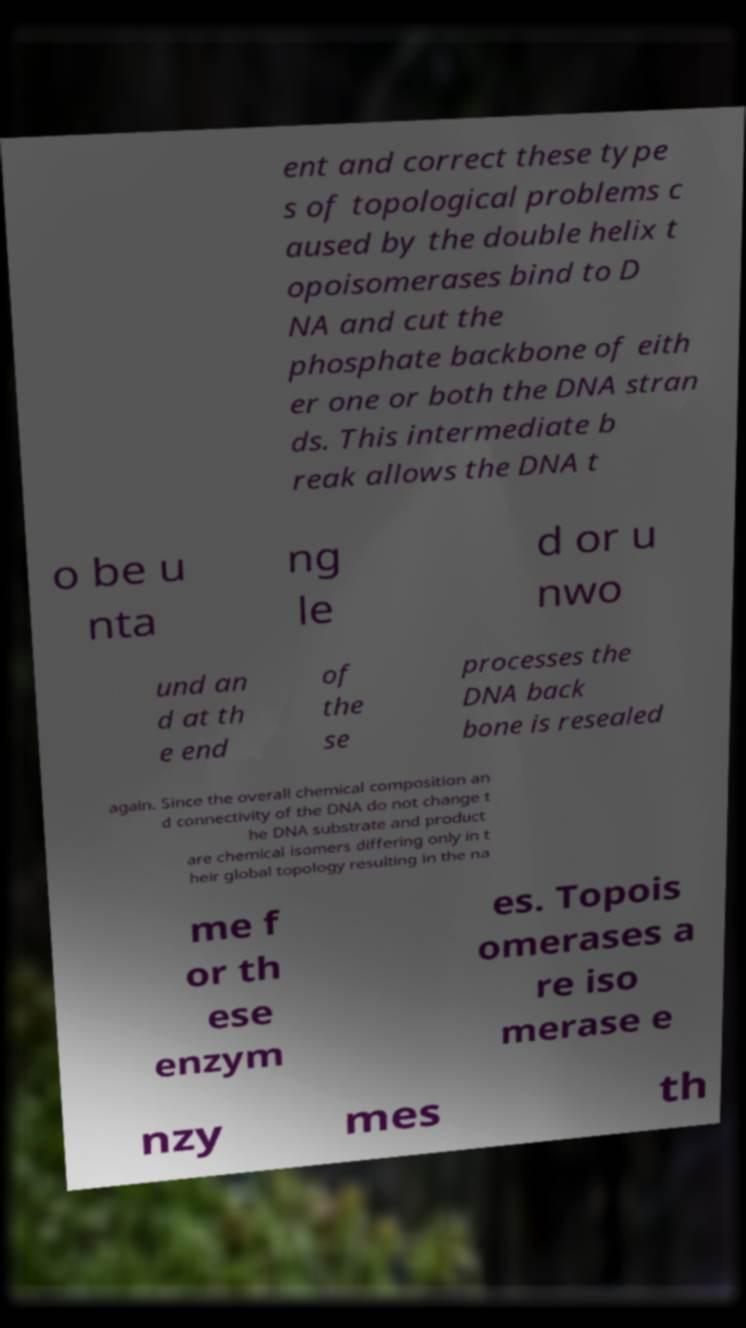Please read and relay the text visible in this image. What does it say? ent and correct these type s of topological problems c aused by the double helix t opoisomerases bind to D NA and cut the phosphate backbone of eith er one or both the DNA stran ds. This intermediate b reak allows the DNA t o be u nta ng le d or u nwo und an d at th e end of the se processes the DNA back bone is resealed again. Since the overall chemical composition an d connectivity of the DNA do not change t he DNA substrate and product are chemical isomers differing only in t heir global topology resulting in the na me f or th ese enzym es. Topois omerases a re iso merase e nzy mes th 